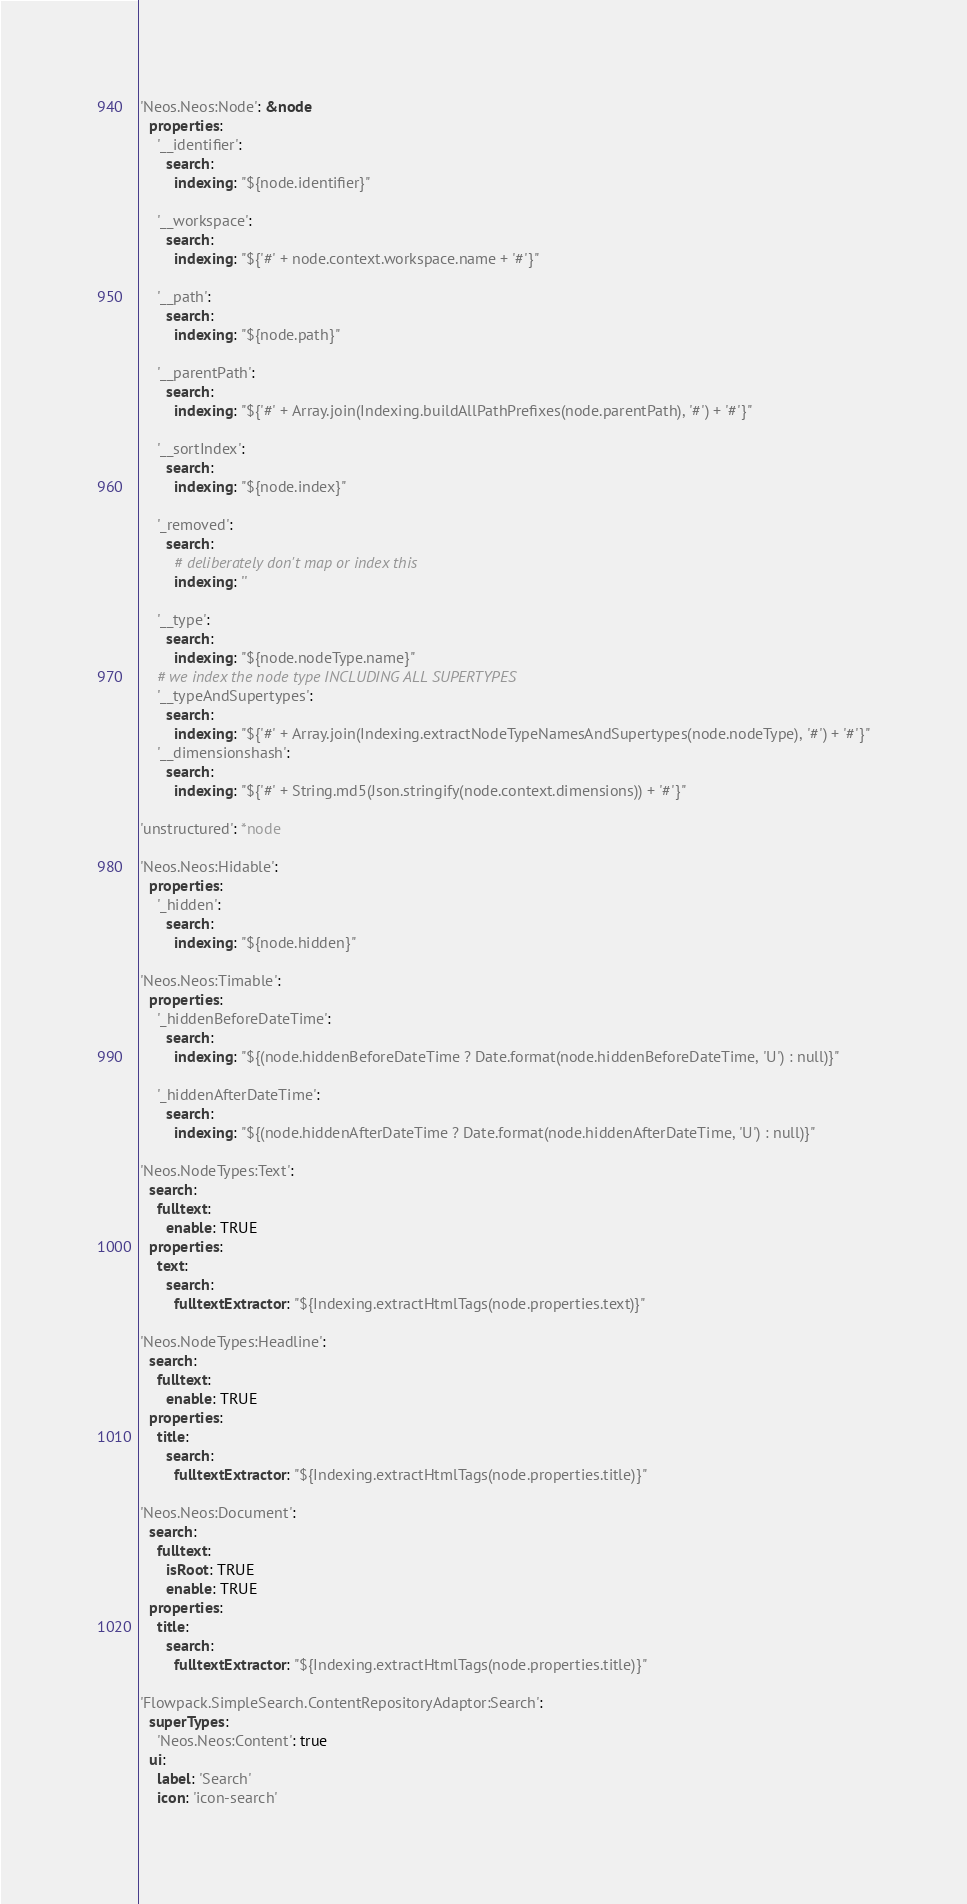Convert code to text. <code><loc_0><loc_0><loc_500><loc_500><_YAML_>
'Neos.Neos:Node': &node
  properties:
    '__identifier':
      search:
        indexing: "${node.identifier}"

    '__workspace':
      search:
        indexing: "${'#' + node.context.workspace.name + '#'}"

    '__path':
      search:
        indexing: "${node.path}"

    '__parentPath':
      search:
        indexing: "${'#' + Array.join(Indexing.buildAllPathPrefixes(node.parentPath), '#') + '#'}"

    '__sortIndex':
      search:
        indexing: "${node.index}"

    '_removed':
      search:
        # deliberately don't map or index this
        indexing: ''

    '__type':
      search:
        indexing: "${node.nodeType.name}"
    # we index the node type INCLUDING ALL SUPERTYPES
    '__typeAndSupertypes':
      search:
        indexing: "${'#' + Array.join(Indexing.extractNodeTypeNamesAndSupertypes(node.nodeType), '#') + '#'}"
    '__dimensionshash':
      search:
        indexing: "${'#' + String.md5(Json.stringify(node.context.dimensions)) + '#'}"

'unstructured': *node

'Neos.Neos:Hidable':
  properties:
    '_hidden':
      search:
        indexing: "${node.hidden}"

'Neos.Neos:Timable':
  properties:
    '_hiddenBeforeDateTime':
      search:
        indexing: "${(node.hiddenBeforeDateTime ? Date.format(node.hiddenBeforeDateTime, 'U') : null)}"

    '_hiddenAfterDateTime':
      search:
        indexing: "${(node.hiddenAfterDateTime ? Date.format(node.hiddenAfterDateTime, 'U') : null)}"

'Neos.NodeTypes:Text':
  search:
    fulltext:
      enable: TRUE
  properties:
    text:
      search:
        fulltextExtractor: "${Indexing.extractHtmlTags(node.properties.text)}"

'Neos.NodeTypes:Headline':
  search:
    fulltext:
      enable: TRUE
  properties:
    title:
      search:
        fulltextExtractor: "${Indexing.extractHtmlTags(node.properties.title)}"

'Neos.Neos:Document':
  search:
    fulltext:
      isRoot: TRUE
      enable: TRUE
  properties:
    title:
      search:
        fulltextExtractor: "${Indexing.extractHtmlTags(node.properties.title)}"

'Flowpack.SimpleSearch.ContentRepositoryAdaptor:Search':
  superTypes:
    'Neos.Neos:Content': true
  ui:
    label: 'Search'
    icon: 'icon-search'
</code> 